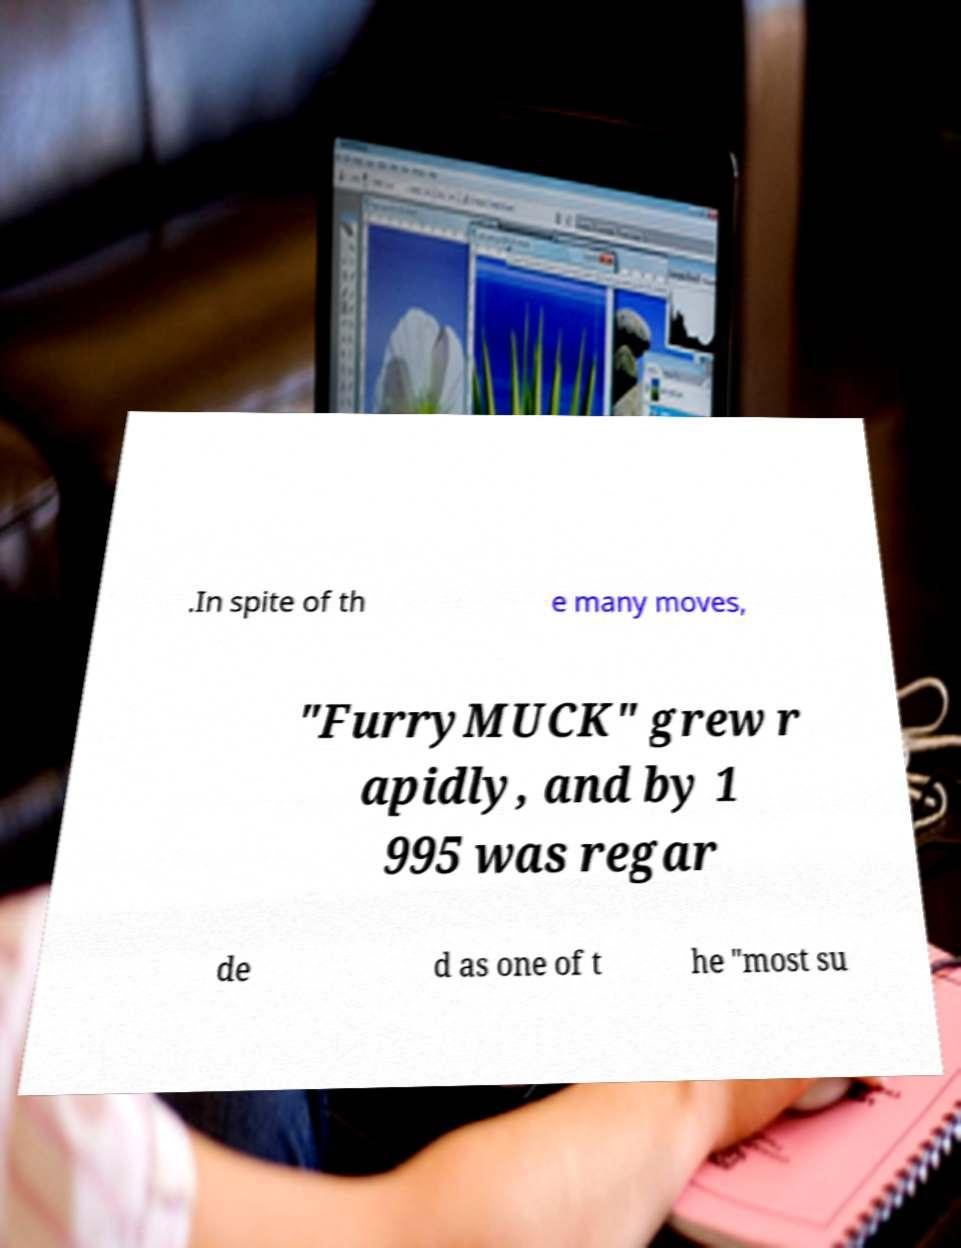Please identify and transcribe the text found in this image. .In spite of th e many moves, "FurryMUCK" grew r apidly, and by 1 995 was regar de d as one of t he "most su 